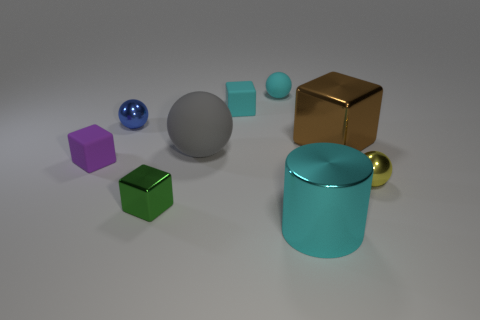There is a object that is behind the tiny matte block that is behind the block to the left of the small metallic block; how big is it?
Ensure brevity in your answer.  Small. Are there fewer small yellow spheres to the left of the large rubber object than metal things to the left of the large cylinder?
Give a very brief answer. Yes. What number of spheres have the same material as the large brown thing?
Your response must be concise. 2. Are there any tiny blocks behind the tiny metal sphere on the right side of the matte ball behind the tiny blue metal thing?
Your answer should be very brief. Yes. There is a tiny green thing that is made of the same material as the big cyan cylinder; what shape is it?
Provide a succinct answer. Cube. Is the number of small purple rubber cylinders greater than the number of blue spheres?
Provide a short and direct response. No. There is a green object; is its shape the same as the big metal thing that is behind the yellow sphere?
Provide a short and direct response. Yes. What is the material of the tiny cyan block?
Offer a very short reply. Rubber. The small matte block in front of the rubber block that is right of the small cube that is to the left of the tiny blue sphere is what color?
Your answer should be very brief. Purple. There is a small blue object that is the same shape as the yellow metallic thing; what is its material?
Your response must be concise. Metal. 